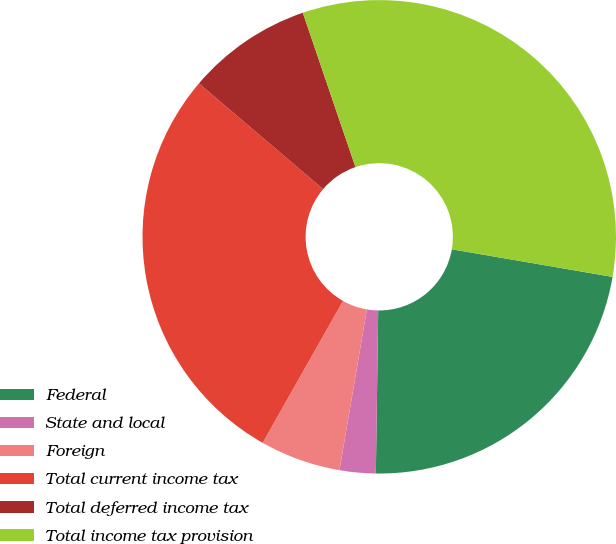Convert chart. <chart><loc_0><loc_0><loc_500><loc_500><pie_chart><fcel>Federal<fcel>State and local<fcel>Foreign<fcel>Total current income tax<fcel>Total deferred income tax<fcel>Total income tax provision<nl><fcel>22.52%<fcel>2.46%<fcel>5.51%<fcel>28.02%<fcel>8.55%<fcel>32.94%<nl></chart> 